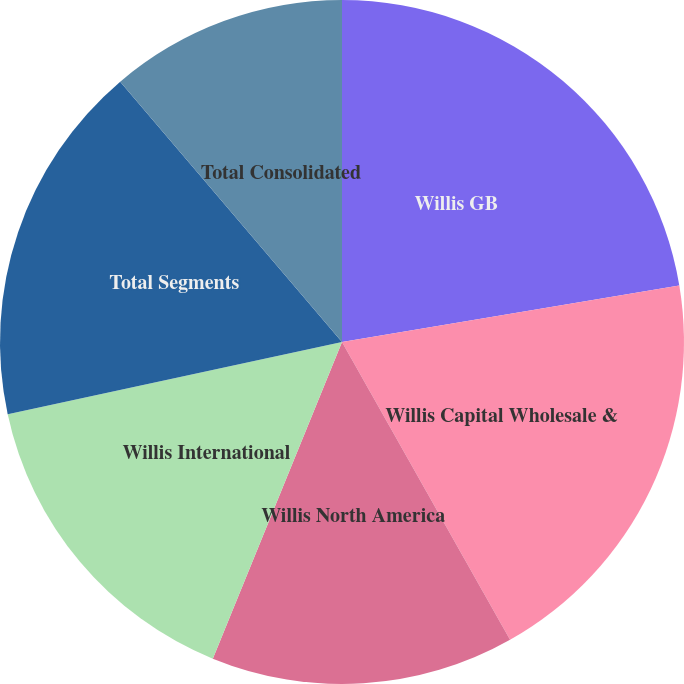<chart> <loc_0><loc_0><loc_500><loc_500><pie_chart><fcel>Willis GB<fcel>Willis Capital Wholesale &<fcel>Willis North America<fcel>Willis International<fcel>Total Segments<fcel>Total Consolidated<nl><fcel>22.36%<fcel>19.46%<fcel>14.34%<fcel>15.45%<fcel>17.15%<fcel>11.23%<nl></chart> 